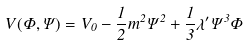Convert formula to latex. <formula><loc_0><loc_0><loc_500><loc_500>V ( \Phi , \Psi ) = V _ { 0 } - \frac { 1 } { 2 } m ^ { 2 } \Psi ^ { 2 } + \frac { 1 } { 3 } \lambda ^ { \prime } \Psi ^ { 3 } \Phi</formula> 